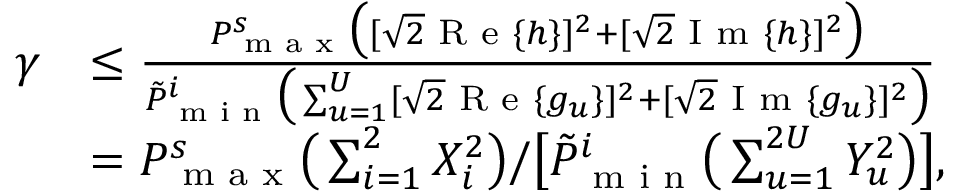Convert formula to latex. <formula><loc_0><loc_0><loc_500><loc_500>\begin{array} { r l } { \gamma } & { \leq \frac { P _ { \max } ^ { s } \left ( [ \sqrt { 2 } R e \{ h \} ] ^ { 2 } + [ \sqrt { 2 } I m \{ h \} ] ^ { 2 } \right ) } { \tilde { P } _ { \min } ^ { i } \left ( \sum _ { u = 1 } ^ { U } [ \sqrt { 2 } R e \{ g _ { u } \} ] ^ { 2 } + [ \sqrt { 2 } I m \{ g _ { u } \} ] ^ { 2 } \right ) } } \\ & { = P _ { \max } ^ { s } \left ( \sum _ { i = 1 } ^ { 2 } X _ { i } ^ { 2 } \right ) / \left [ \tilde { P } _ { \min } ^ { i } \left ( \sum _ { u = 1 } ^ { 2 U } Y _ { u } ^ { 2 } \right ) \right ] , } \end{array}</formula> 